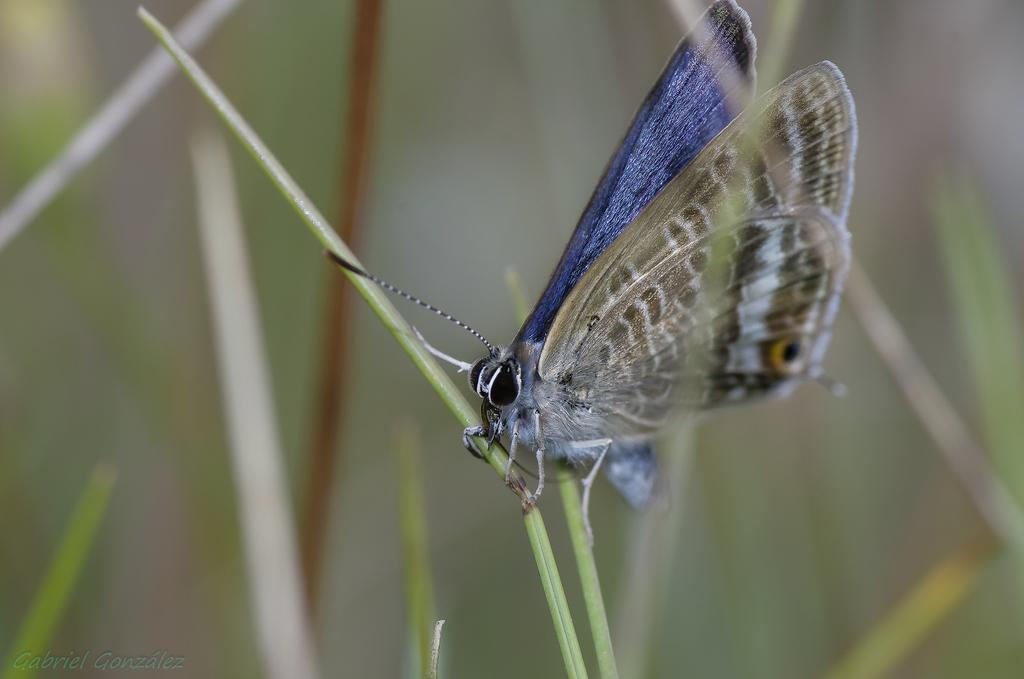What is the main subject of the image? There is a butterfly in the image. Can you describe the color of the butterfly? The butterfly is brown and blue in color. Where is the butterfly located in the image? The butterfly is on the grass. How would you describe the background of the image? The background of the image is blurred. What type of action is the butterfly performing in the image? The butterfly is not performing any action in the image; it is simply resting on the grass. How is the distribution of the butterfly's wings in the image? The butterfly's wings are not mentioned in the provided facts, so we cannot determine their distribution in the image. 